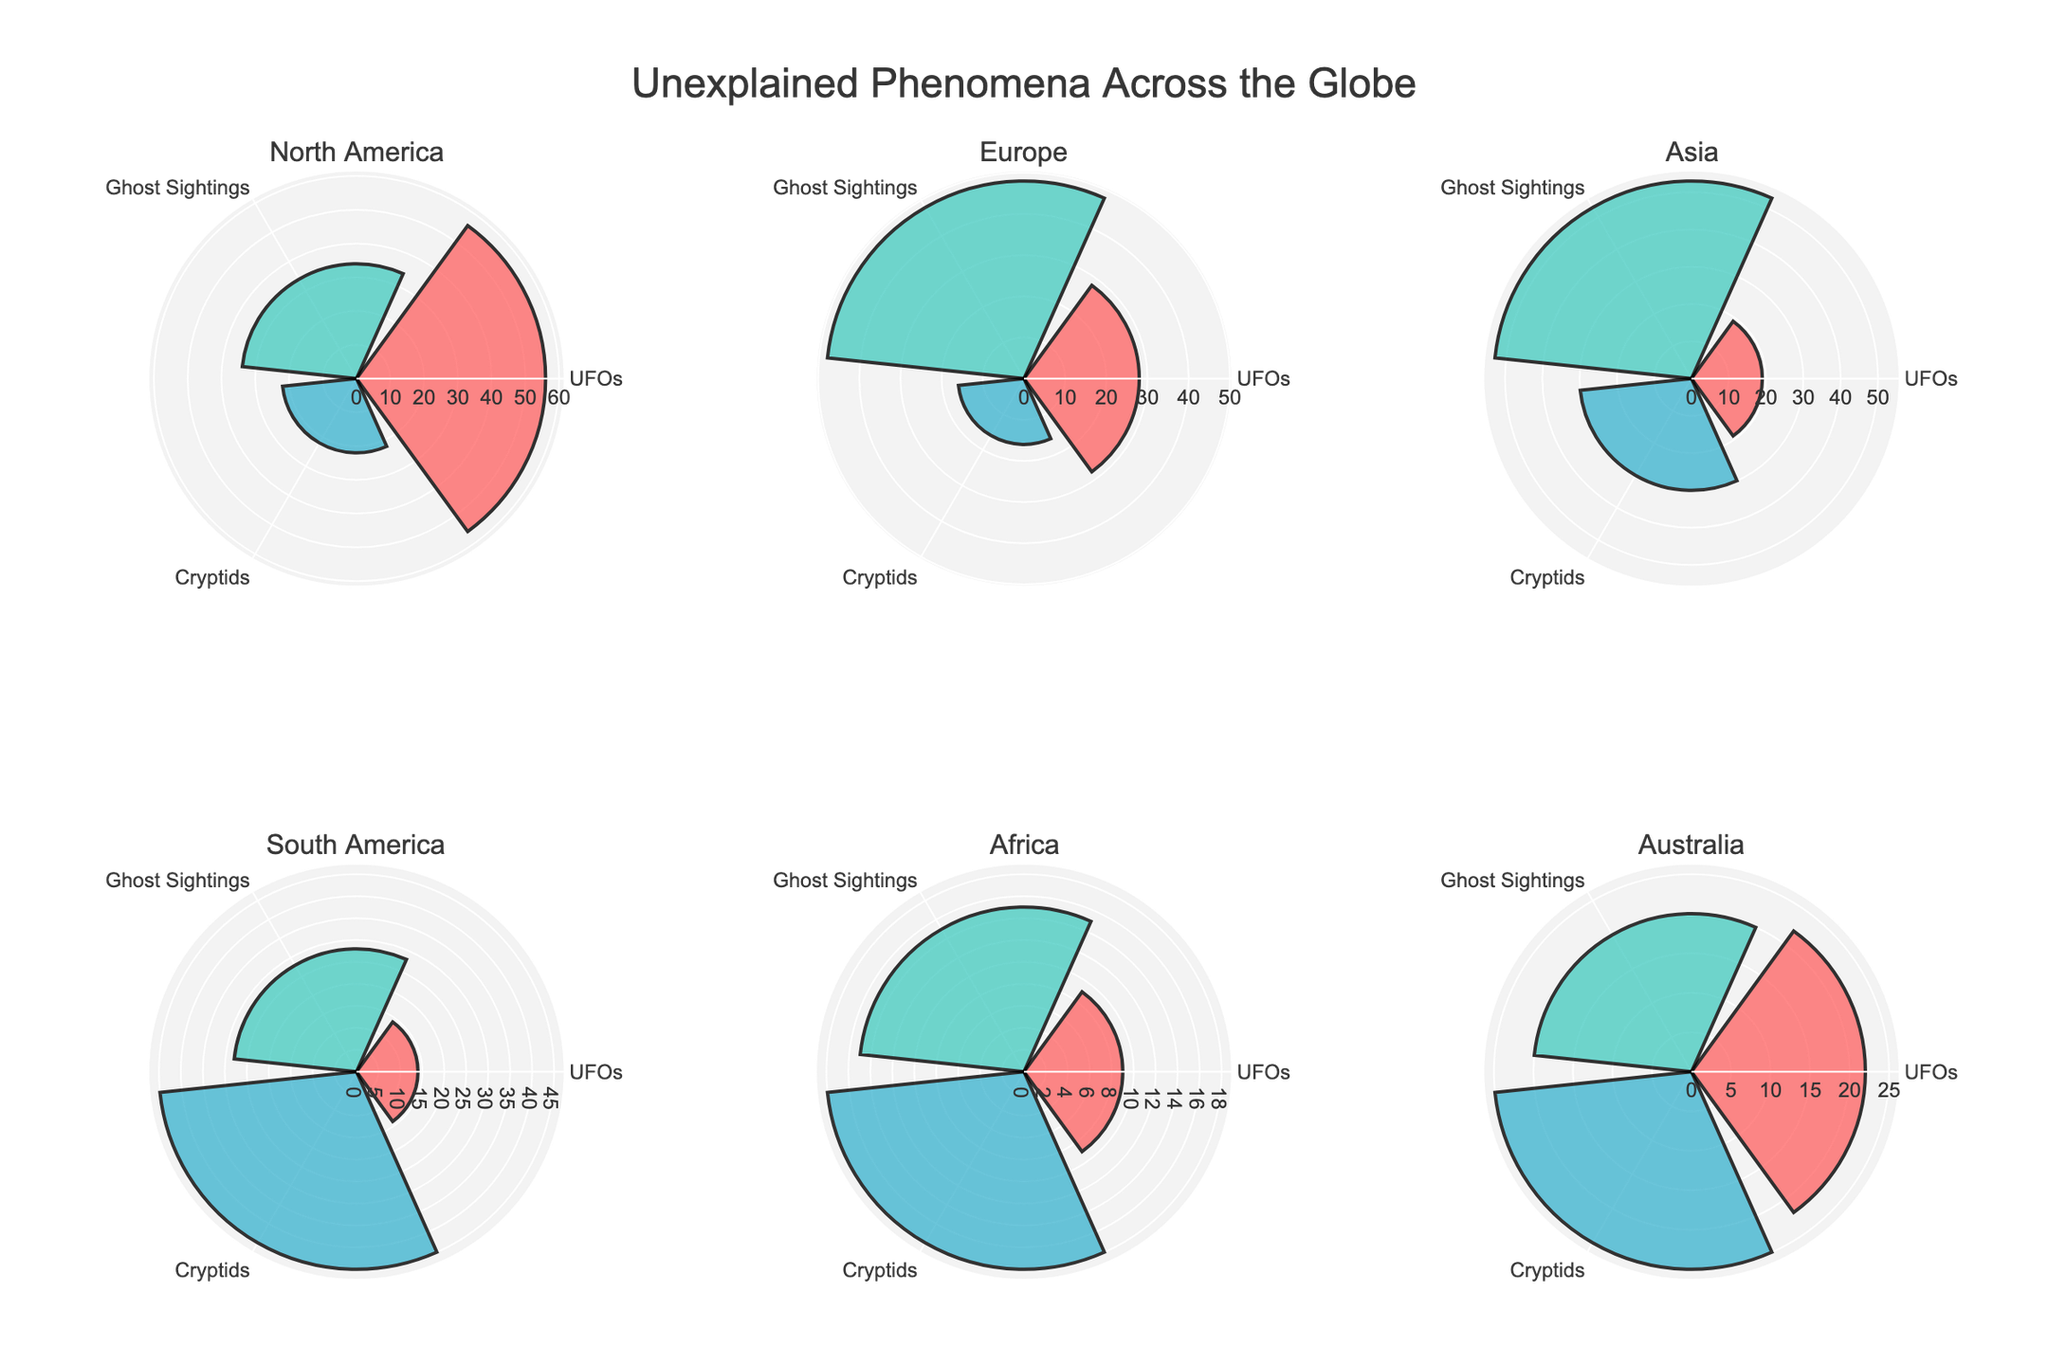What are the three types of unexplained phenomena shown in each subplot? The three types of unexplained phenomena shown in each subplot are identified by the categories listed in the theta axis of the rose (polar) chart. Each geographic region subplot contains only these types.
Answer: UFOs, Ghost Sightings, Cryptids Which region has the highest frequency of ghost sightings? By comparing the radial lengths (r-values) for ghost sightings across all the regions, the longest bar in the ghost sightings category belongs to the Asia subplot.
Answer: Asia How does the frequency of UFO sightings in North America compare to Europe? In the North America subplot, the radial length for UFO sightings is 56 whereas, in Europe, it is 28. By comparing these values, UFO sightings in North America are seen to have a higher frequency.
Answer: UFO sightings are higher in North America What is the total frequency of all types of unexplained phenomena in Australia? Sum the frequencies of UFOs, ghost sightings, and cryptids in the Australia subplot. The frequencies are 22, 20, and 25 respectively; adding them gives 22 + 20 + 25 = 67.
Answer: 67 Which region has the lowest total frequency of unexplained phenomena? To find this, sum the frequencies (UFOs, ghost sightings, cryptids) for each region and compare. For Africa, the sums are 9 + 15 + 18 = 42, which is the lowest compared to other regions.
Answer: Africa Between cryptid sightings in Asia and South America, which is more frequent? Compare the radial lengths for cryptid sightings in the Asia and South America subplots. Asia shows a value of 30, whereas South America shows a value of 45.
Answer: Cryptid sightings are more frequent in South America What is the difference in frequency between ghost sightings and cryptid sightings in Europe? To find the difference, subtract the frequency of cryptid sightings from ghost sightings in the Europe subplot: 48 - 16 = 32.
Answer: 32 In which region is the frequency of cryptid sightings the highest? By inspecting the radial lengths for cryptid sightings across all subplots, South America has the highest value for cryptid sightings at 45.
Answer: South America How does the frequency of unexplained phenomena in Africa compare between UFOs and ghost sightings? In the Africa subplot, the radial length for UFO sightings is 9 and for ghost sightings is 15. Comparing these, ghost sightings have a higher frequency.
Answer: Ghost sightings have a higher frequency than UFO sightings in Africa Which phenomenon type has the lowest frequency in North America? In the North America subplot, the bars for each phenomenon can be compared, and the smallest radial length belongs to cryptids at a value of 22.
Answer: Cryptids 